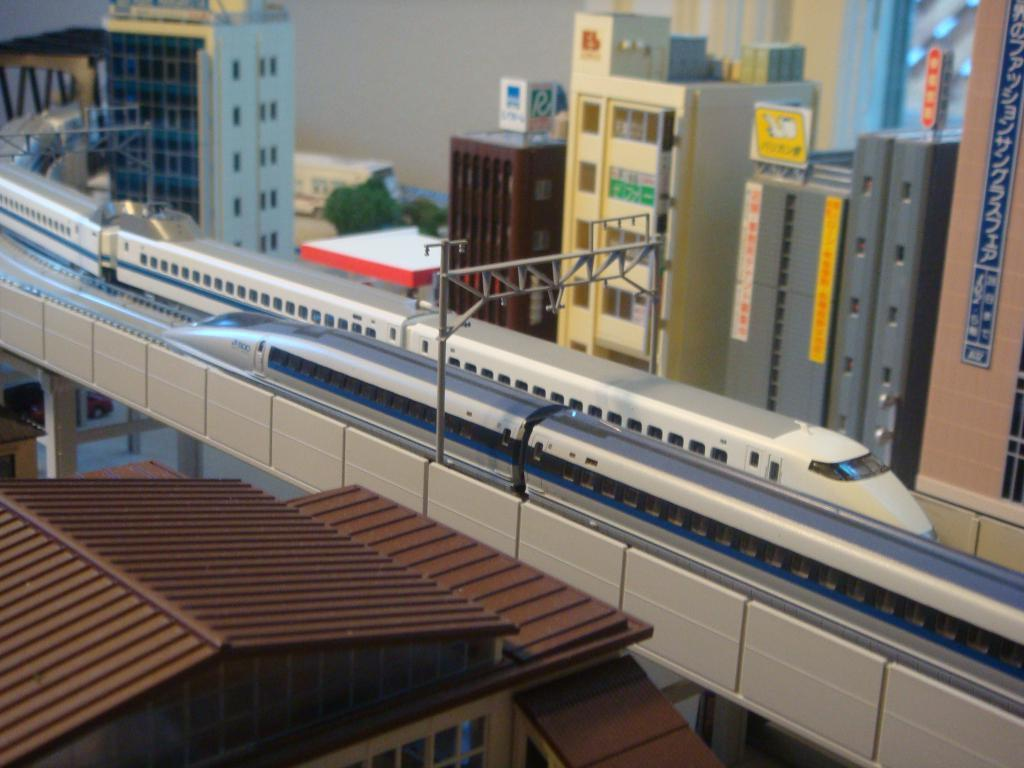What type of structures can be seen in the image? There are buildings, a roof house, and a bridge in the image. What is the purpose of the poles in the image? The purpose of the poles in the image is not specified, but they could be for supporting power lines or other infrastructure. What mode of transportation is visible in the image? Trains are passing on the railway track in the image. What type of vegetation is present in the image? There are trees in the image. How does the aunt travel to work in the image? There is no information about an aunt or her mode of transportation in the image. What type of journey does the train make in the image? The image does not provide information about the train's journey or destination. 